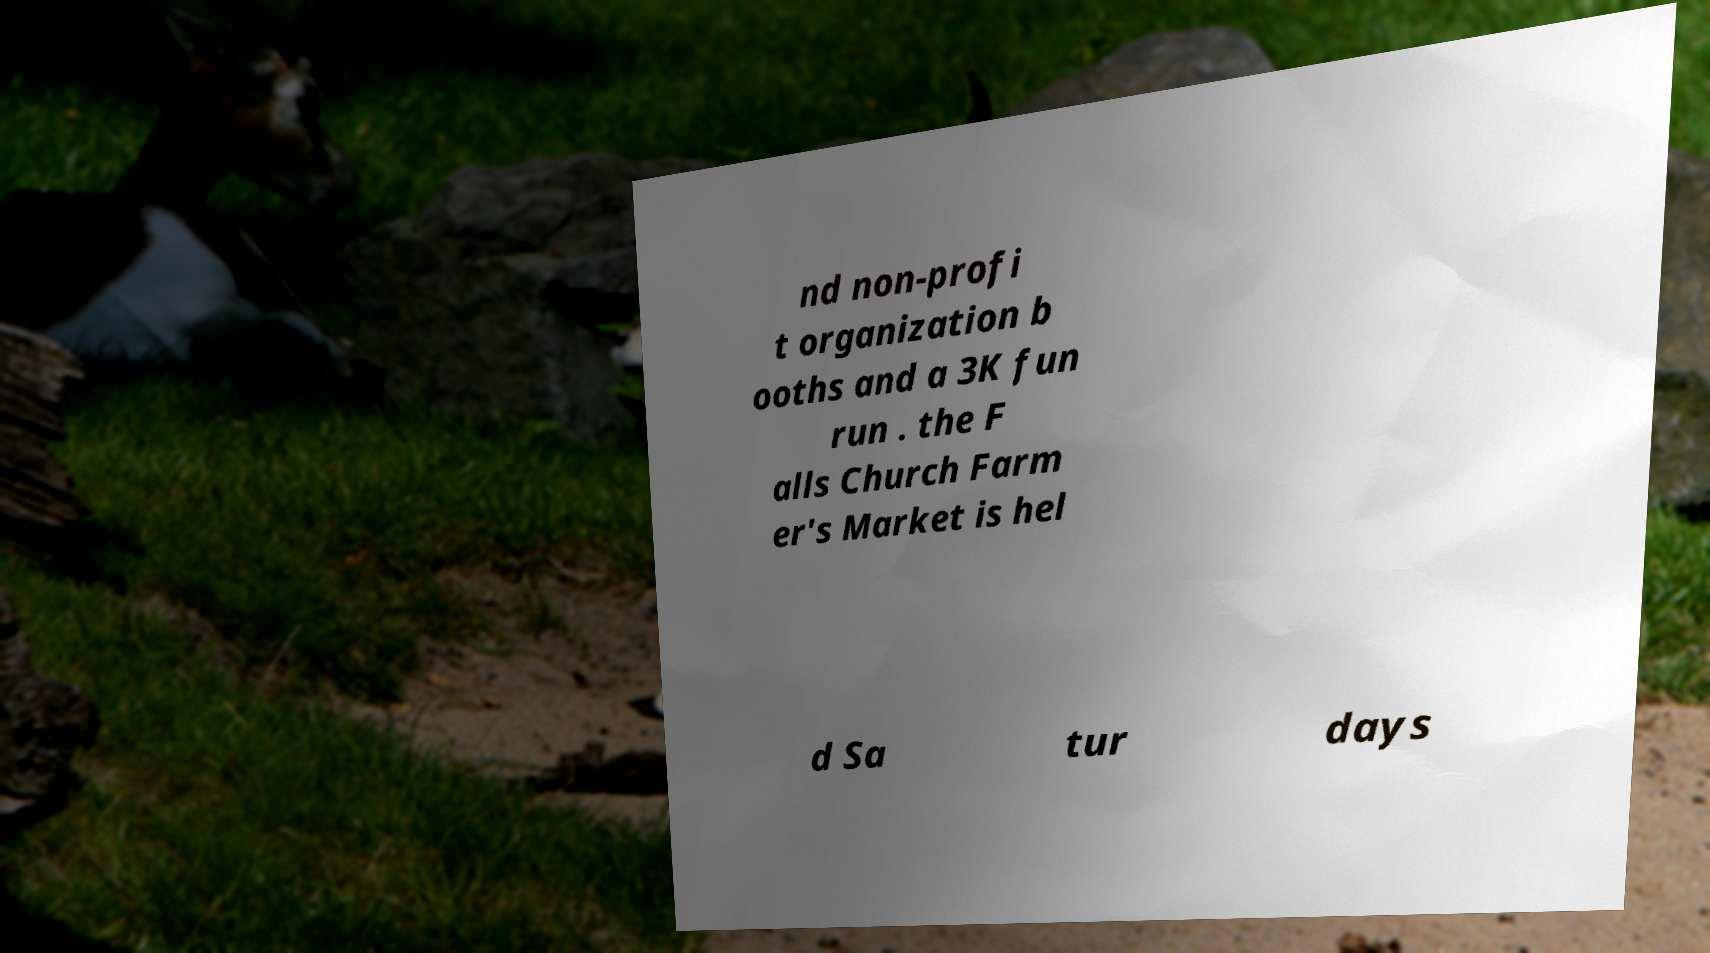There's text embedded in this image that I need extracted. Can you transcribe it verbatim? nd non-profi t organization b ooths and a 3K fun run . the F alls Church Farm er's Market is hel d Sa tur days 